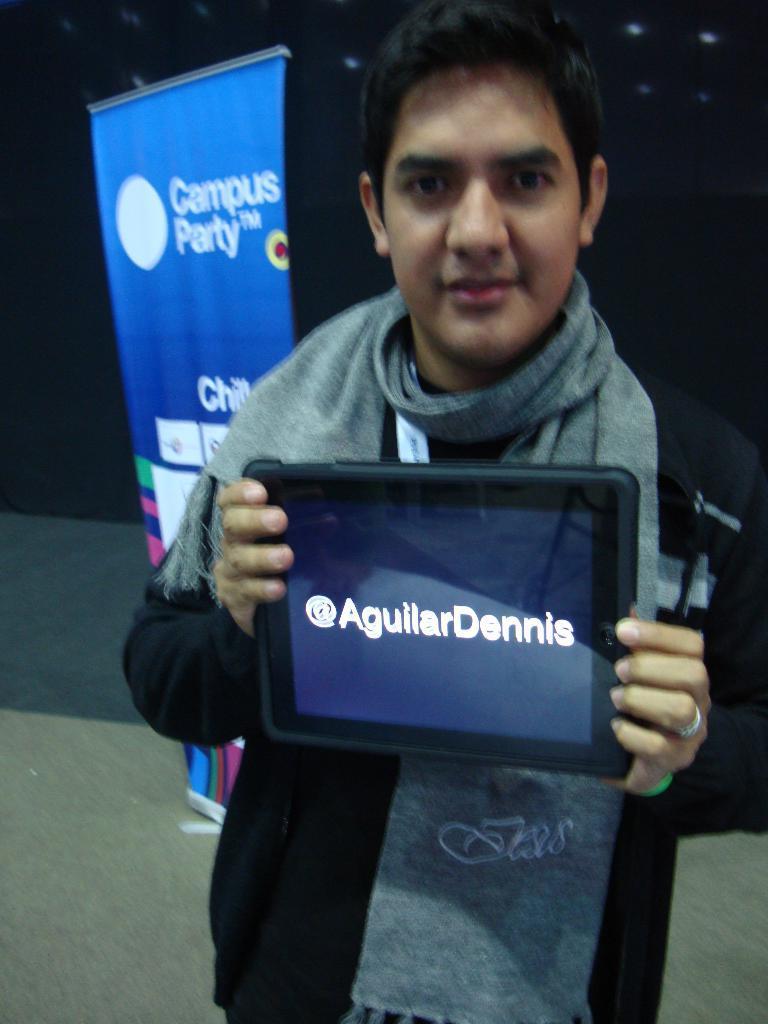Please provide a concise description of this image. In the image there is a man standing in the foreground, he is holding some gadget with his hands and behind the man there is a banner. 